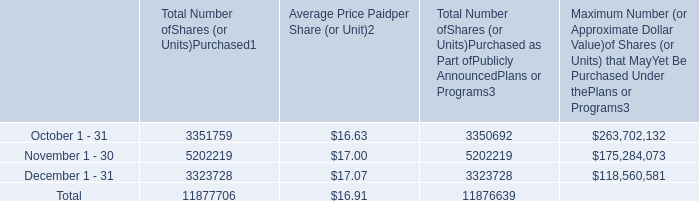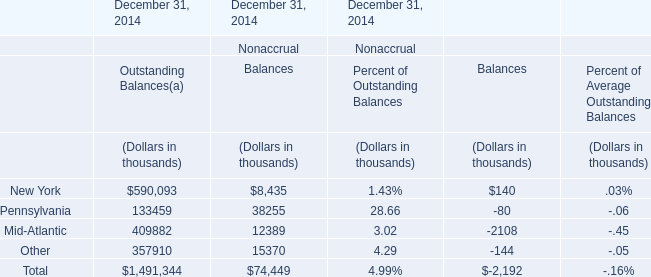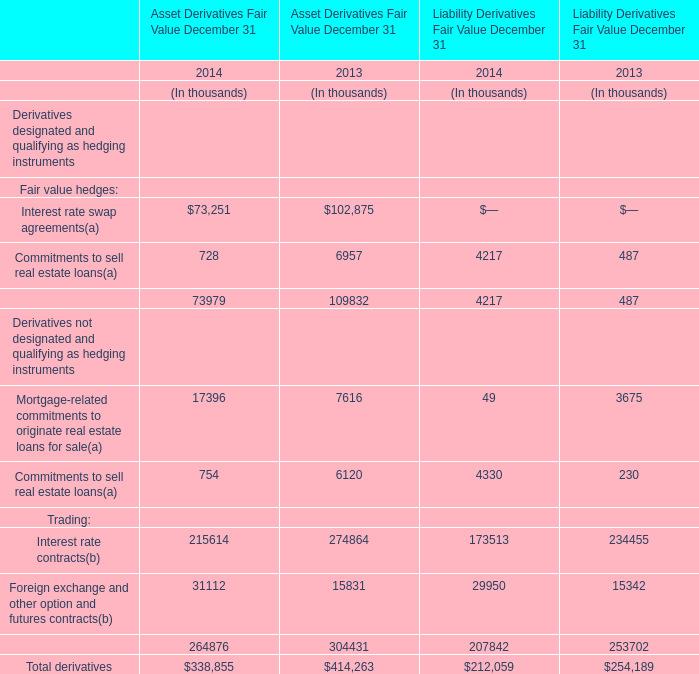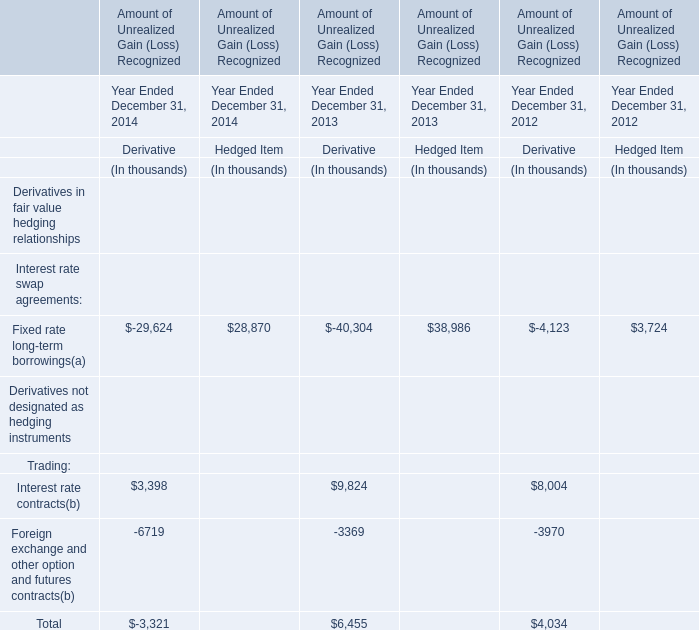What is the sum of the Total Asset Derivatives Fair Value in the year where Total Liability Derivatives Fair Value is greater than 250000 thousand? (in thousand) 
Answer: 414263. 